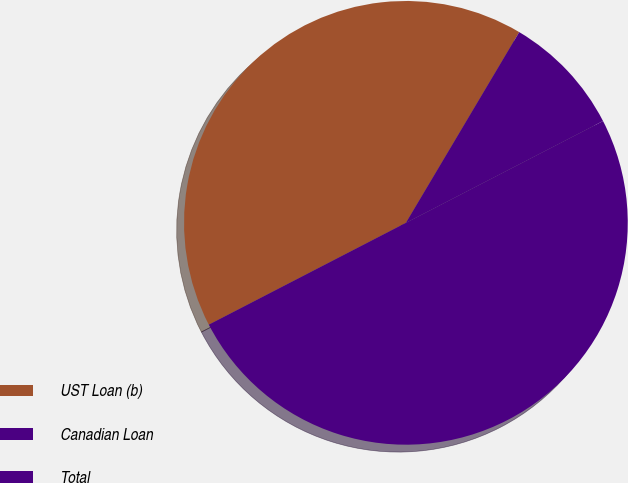<chart> <loc_0><loc_0><loc_500><loc_500><pie_chart><fcel>UST Loan (b)<fcel>Canadian Loan<fcel>Total<nl><fcel>41.12%<fcel>8.88%<fcel>50.0%<nl></chart> 